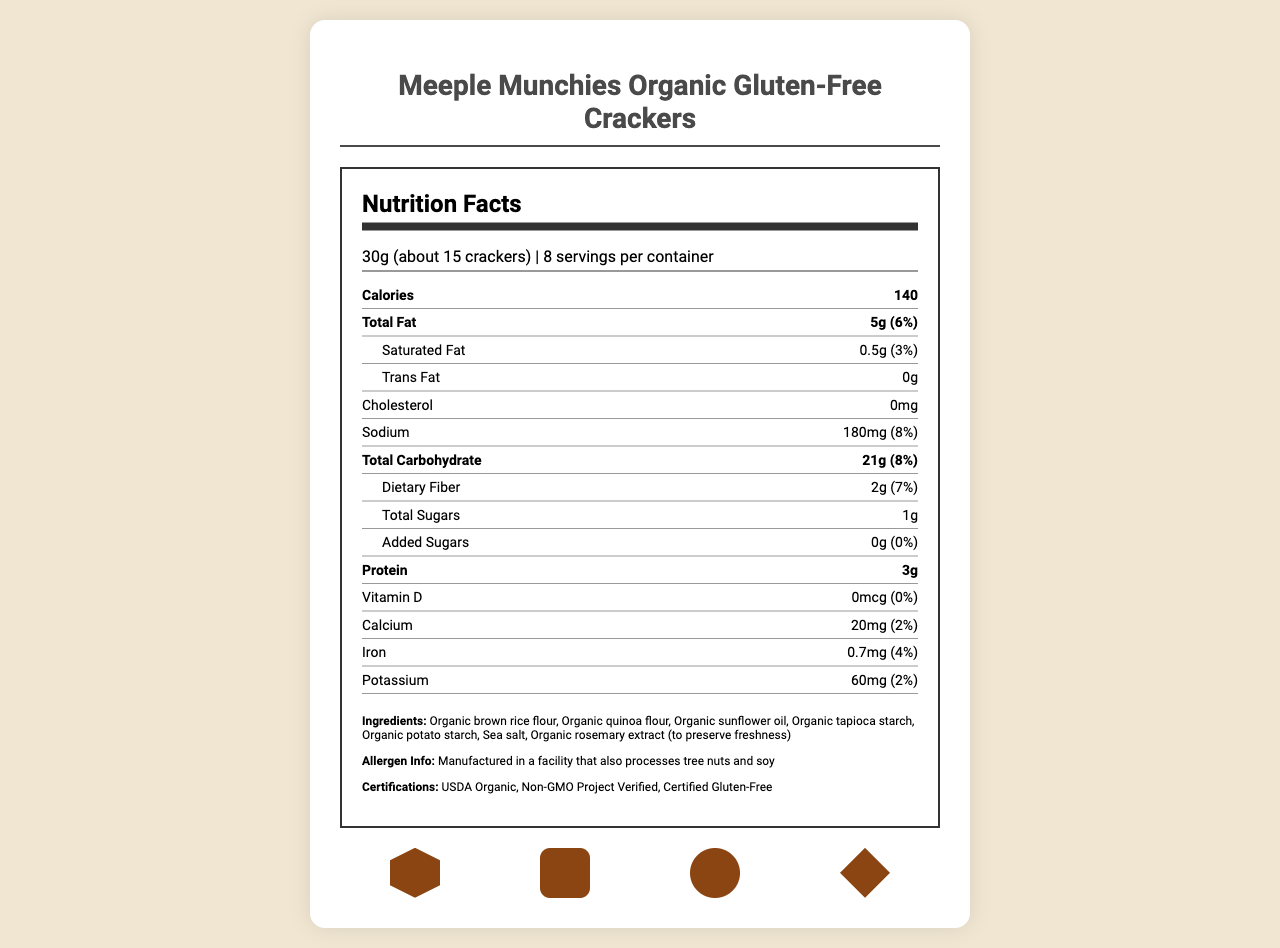what is the serving size? The serving size is listed at the top of the Nutrition Facts section.
Answer: 30g (about 15 crackers) how many calories are in one serving? The number of calories per serving is listed in the bold "Calories" row.
Answer: 140 what is the total fat content per serving? The total fat content per serving is listed in the bold "Total Fat" row.
Answer: 5g how much sodium is in one serving, and what is its daily value percentage? The sodium content and its daily value percentage are listed under the "Sodium" row.
Answer: 180mg, 8% how many grams of dietary fiber are in each serving? The dietary fiber content per serving is listed under the "Dietary Fiber" row.
Answer: 2g which of the following certifications does this product have: A. USDA Organic B. Fair Trade C. Certified Gluten-Free The certifications listed include USDA Organic, Non-GMO Project Verified, and Certified Gluten-Free.
Answer: A, C what is the allergen information provided for this product? The allergen information is provided in the Ingredients section.
Answer: Manufactured in a facility that also processes tree nuts and soy which ingredients are used to preserve freshness? A. Sea salt B. Organic sunflower oil C. Organic rosemary extract The ingredient used to preserve freshness is listed as Organic rosemary extract.
Answer: C what's the description of the cracker's flavor? The flavor description is provided at the end of the document.
Answer: Lightly salted with a hint of rosemary, perfect for snacking during game nights how many servings are in each container? The number of servings per container is listed under the Nutrition Facts section.
Answer: 8 does this product contain any trans fat? The document explicitly states that the trans fat content is 0g.
Answer: No summarize the main idea of the document The document's main purpose is to inform consumers about the nutritional content, ingredients, allergen warnings, certifications, and unique selling points (like game piece shapes) of the crackers.
Answer: The document provides the nutrition facts, ingredients, allergen information, certifications, and characteristics of Meeple Munchies Organic Gluten-Free Crackers. It highlights that each serving size is 30g (about 15 crackers), the crackers are organic, gluten-free, and shaped like popular board game pieces, and are lightly salted with a hint of rosemary. The packaging is resealable and made from 30% post-consumer recycled materials. what is the percentage of daily value for calcium in one serving? The daily value percentage for calcium is listed under the "Calcium" row.
Answer: 2% does the product contain added sugars? If yes, how much? The added sugars content is listed as 0g with a 0% daily value.
Answer: No, 0g what types of game piece shapes are the crackers designed to resemble? A. Meeples B. Dice C. Resource tokens D. Victory point markers E. All of the above The crackers are shaped like Meeples, Dice, Resource tokens, and Victory point markers.
Answer: E how many grams of protein are in one serving of these crackers? The protein content per serving is listed as 3g in the bold "Protein" row.
Answer: 3g how is the packaging described in terms of sustainability? The sustainability note mentions that the package is made from 30% post-consumer recycled materials.
Answer: Package made from 30% post-consumer recycled materials what is the main oil ingredient in the crackers? Organic sunflower oil is listed among the ingredients.
Answer: Organic sunflower oil where are these crackers manufactured? The document mentions that the product is manufactured in a facility that processes tree nuts and soy, but does not specify the exact location of the manufacturing facility.
Answer: Not enough information 